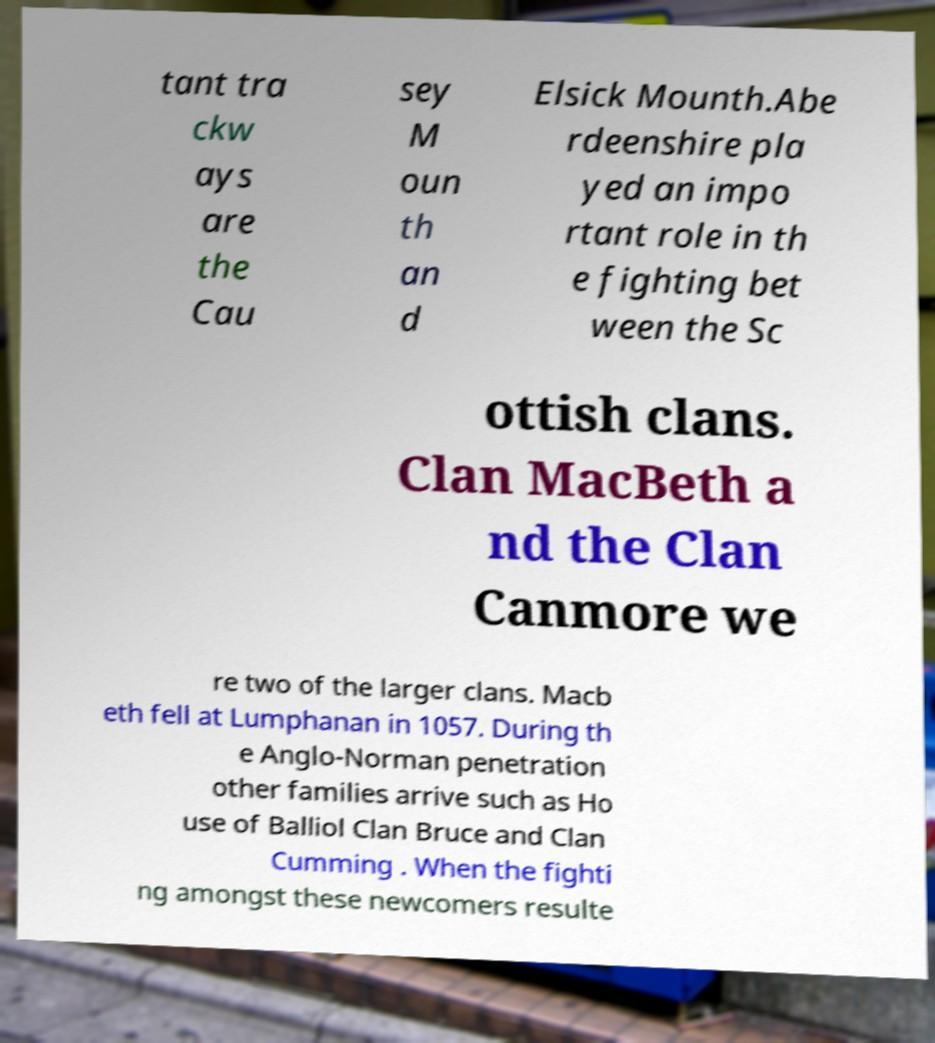Can you accurately transcribe the text from the provided image for me? tant tra ckw ays are the Cau sey M oun th an d Elsick Mounth.Abe rdeenshire pla yed an impo rtant role in th e fighting bet ween the Sc ottish clans. Clan MacBeth a nd the Clan Canmore we re two of the larger clans. Macb eth fell at Lumphanan in 1057. During th e Anglo-Norman penetration other families arrive such as Ho use of Balliol Clan Bruce and Clan Cumming . When the fighti ng amongst these newcomers resulte 